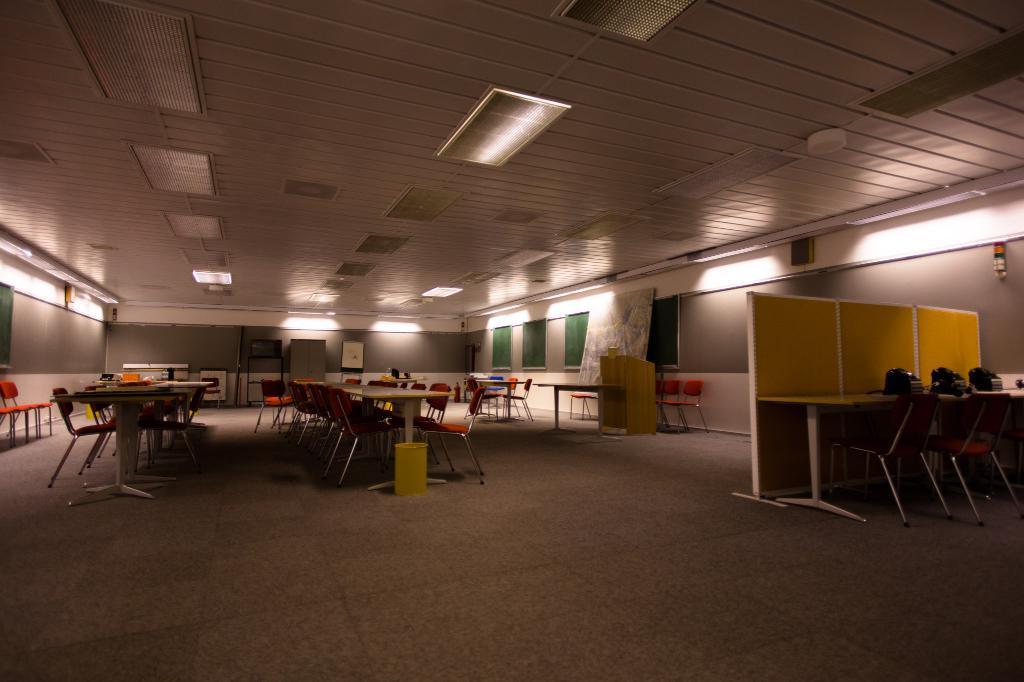Please provide a concise description of this image. In this image we can see table, chairs, dustbin, cabins, telephones, desk, boards, lights. In the background there is wall. 